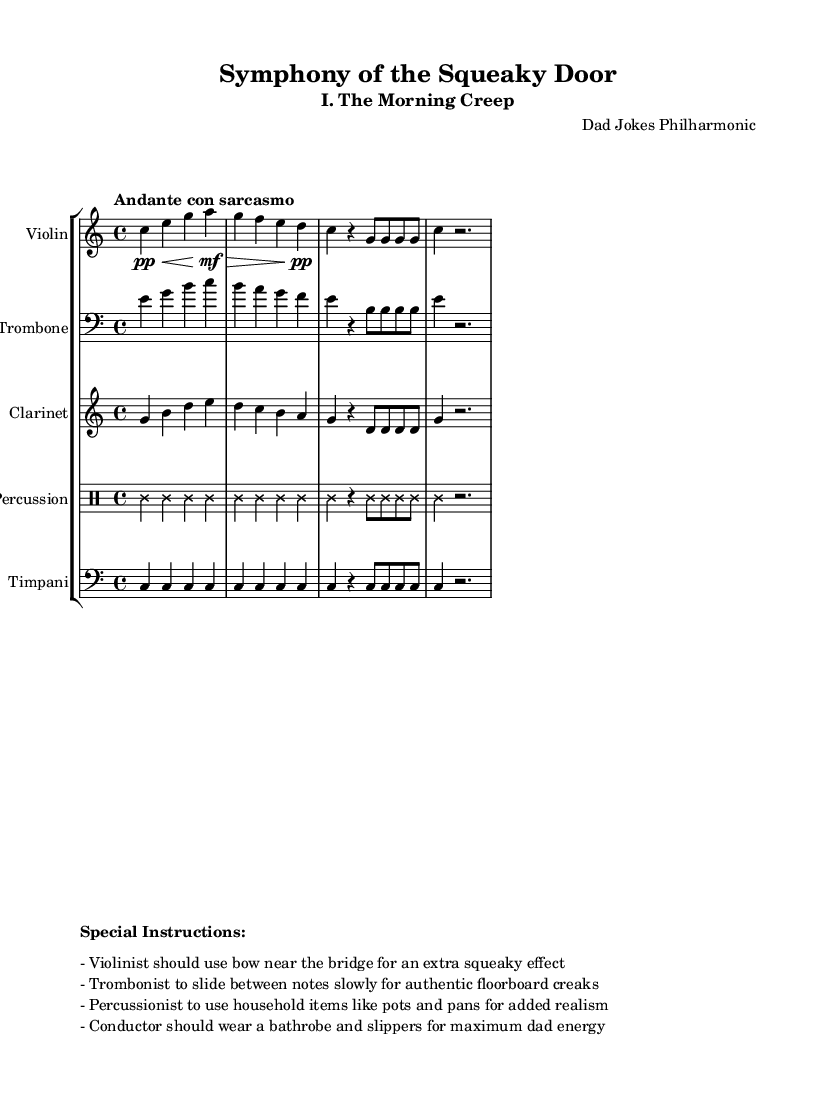What is the key signature of this music? The key signature is C major, which has no sharps or flats.
Answer: C major What is the time signature of this piece? The time signature shown in the music is four beats in a measure, represented as 4/4.
Answer: 4/4 What is the tempo marking of this piece? The tempo marking indicates it should be played slowly with a hint of sarcasm, which is described as "Andante con sarcasmo."
Answer: Andante con sarcasmo How many instruments are featured in this score? The score lists a total of five instruments: violin, trombone, clarinet, percussion, and timpani.
Answer: Five Which instrument uses a clef other than soprano? The trombone and timpani both use bass clef, which is different from the soprano clef used by violin and clarinet.
Answer: Trombone, timpani What special instruction is given for the violinist? The special instruction notes that the violinist should play near the bridge of the instrument to create a squeaky effect.
Answer: Use bow near the bridge What household items are suggested for percussion? The instructions for percussion indicate that household items like pots and pans should be used for added realism in the music.
Answer: Pots and pans 